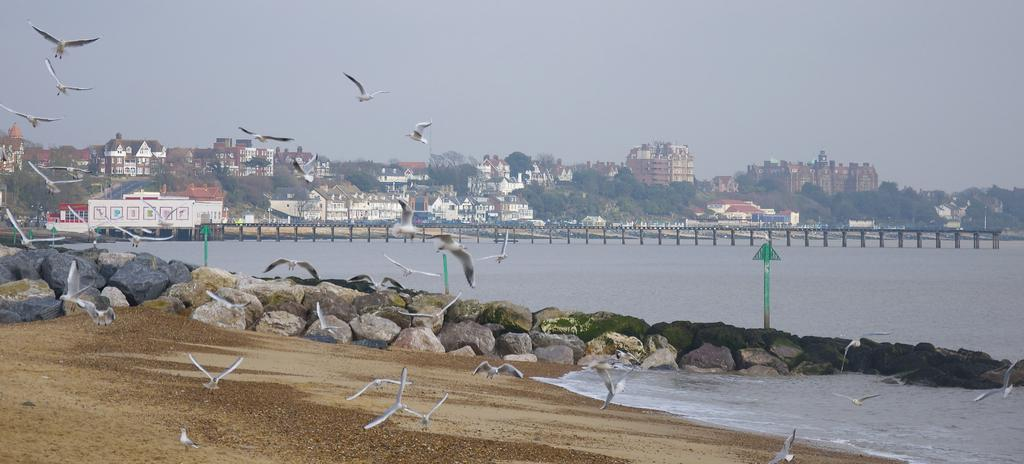What types of structures can be seen in the image? There are buildings and houses in the image. What natural elements are present in the image? There are trees and water visible in the image. What type of animals can be seen in the image? Birds are present in the image. What part of the natural environment is visible in the image? The sky is visible in the image. What type of celery can be seen growing in the image? There is no celery present in the image. 